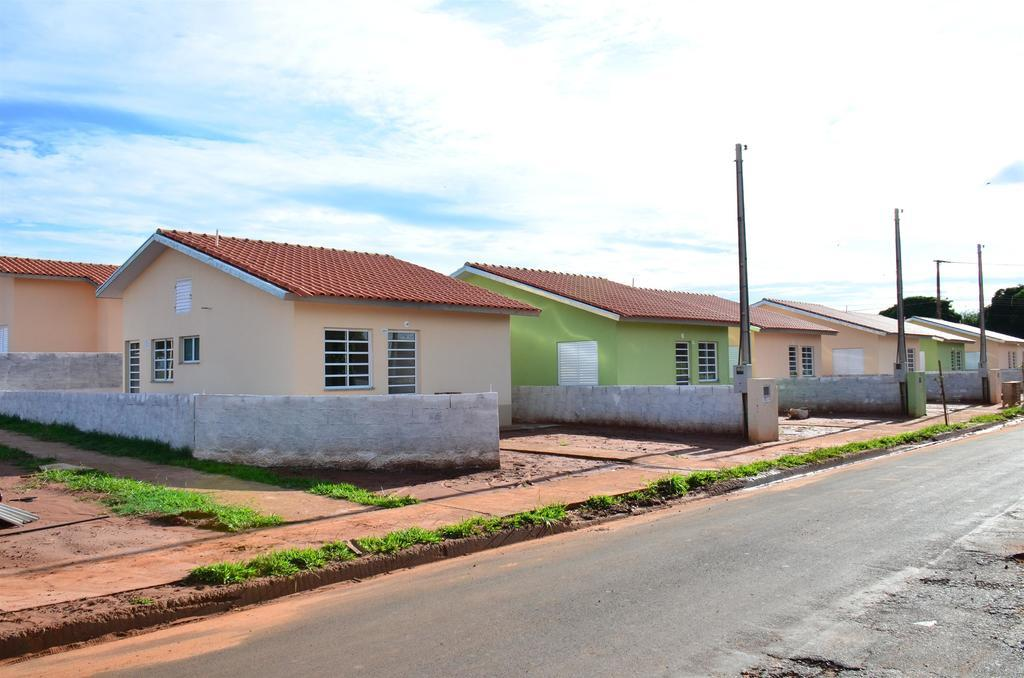What can be seen in the foreground of the picture? There is grass, a road, and soil in the foreground of the picture. What structures are located in the center of the picture? There are houses, a wall, poles, and trees in the center of the picture. What is the condition of the sky in the picture? The sky is sunny in the picture. Can you tell me how many stamps are on the wall in the image? There are no stamps present in the image; the wall is part of a structure and does not have any stamps on it. What type of impulse can be seen affecting the trees in the image? There is no impulse affecting the trees in the image; they are stationary and not being influenced by any external force. 